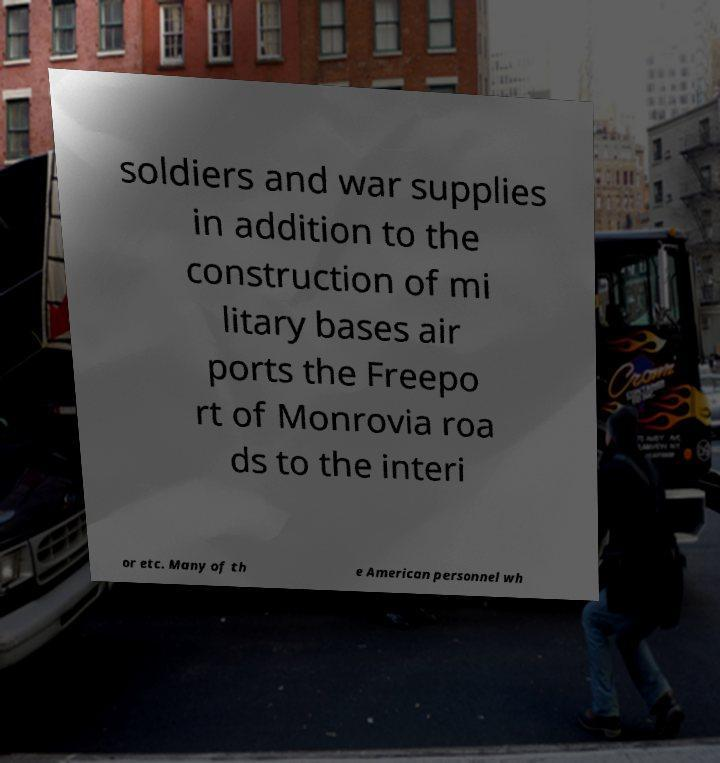Can you read and provide the text displayed in the image?This photo seems to have some interesting text. Can you extract and type it out for me? soldiers and war supplies in addition to the construction of mi litary bases air ports the Freepo rt of Monrovia roa ds to the interi or etc. Many of th e American personnel wh 